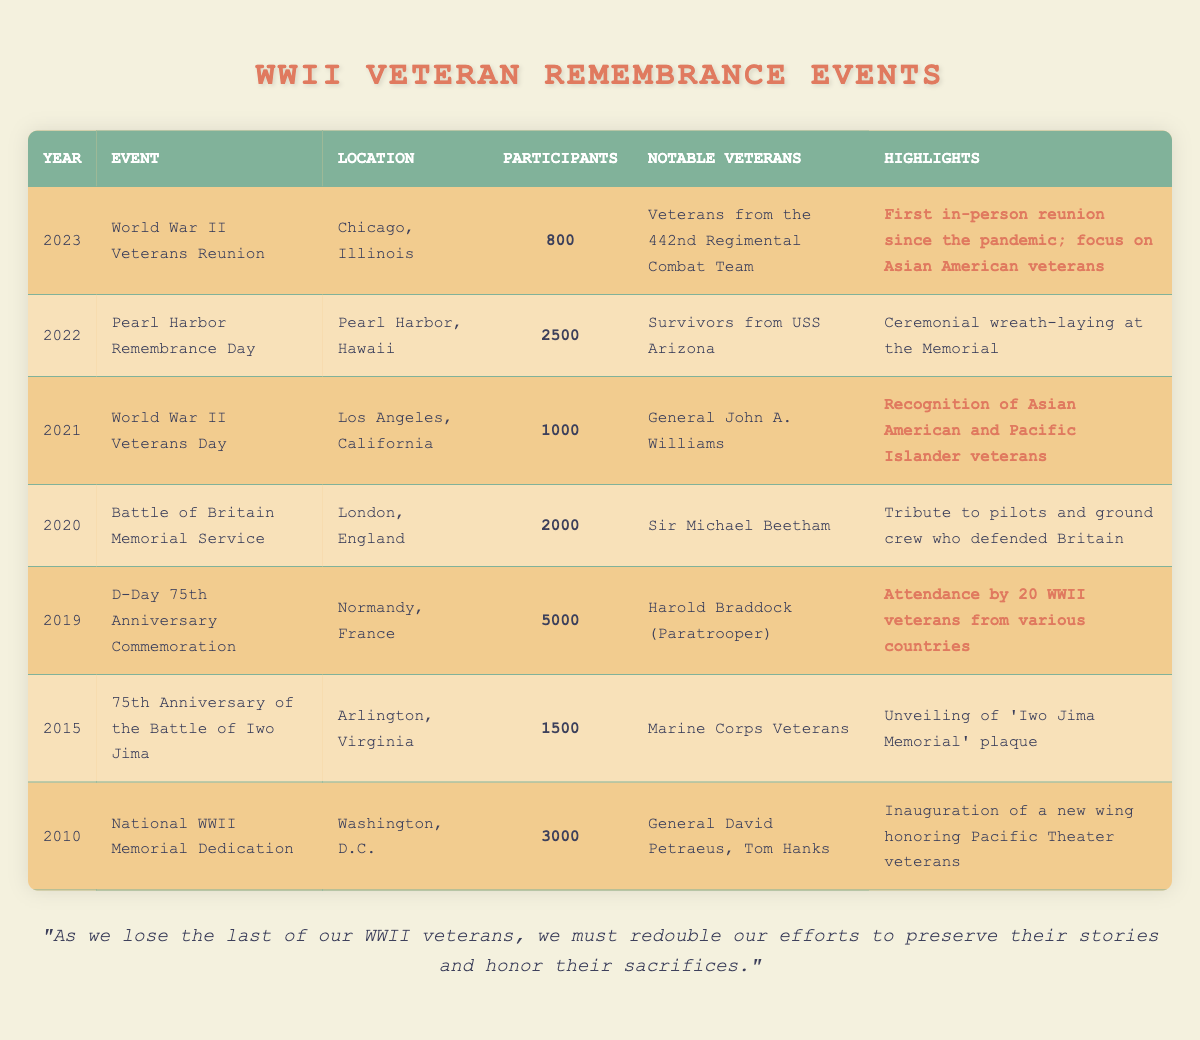How many participants attended the D-Day 75th Anniversary Commemoration? The table states that the D-Day 75th Anniversary Commemoration in 2019 had 5000 participants.
Answer: 5000 What event in 2021 recognized Asian American and Pacific Islander veterans? The table indicates that the World War II Veterans Day event in Los Angeles, California, recognized Asian American and Pacific Islander veterans.
Answer: World War II Veterans Day Which event had the highest number of participants? By comparing the participant numbers—5000 for the D-Day 75th Anniversary Commemoration stands out as the highest when compared to other events.
Answer: D-Day 75th Anniversary Commemoration How many years separated the National WWII Memorial Dedication from the Pearl Harbor Remembrance Day? The Memorial Dedication was in 2010, and the Pearl Harbor Remembrance Day was in 2022. The difference is 2022 - 2010 = 12 years.
Answer: 12 years Was the Battle of Britain Memorial Service held in the same year as the World War II Veterans Reunion? The Battle of Britain Memorial Service occurred in 2020, and the World War II Veterans Reunion took place in 2023, so they were not held in the same year.
Answer: No Which notable veteran was mentioned in the 2015 event? The 2015 event (75th Anniversary of the Battle of Iwo Jima) mentions Marine Corps Veterans as the notable participants.
Answer: Marine Corps Veterans What was the difference in participants between the Battle of Britain Memorial Service and the World War II Veterans Day? The Battle of Britain had 2000 participants, while the World War II Veterans Day had 1000. The difference is 2000 - 1000 = 1000 participants.
Answer: 1000 participants Which two events highlighted Asian American veterans? The 2021 World War II Veterans Day and the 2023 World War II Veterans Reunion both highlighted Asian American veterans according to the table.
Answer: 2021 World War II Veterans Day and 2023 World War II Veterans Reunion What significant highlight occurred during the 2022 Pearl Harbor Remembrance Day? The table indicates that a ceremonial wreath-laying took place at the Memorial during the 2022 Pearl Harbor Remembrance Day.
Answer: Ceremonial wreath-laying What was the total number of participants for events held in 2020 and 2021 combined? For 2020, there were 2000 participants at the Battle of Britain, and for 2021, there were 1000 at the World War II Veterans Day. Thus, the total is 2000 + 1000 = 3000 participants combined.
Answer: 3000 participants 